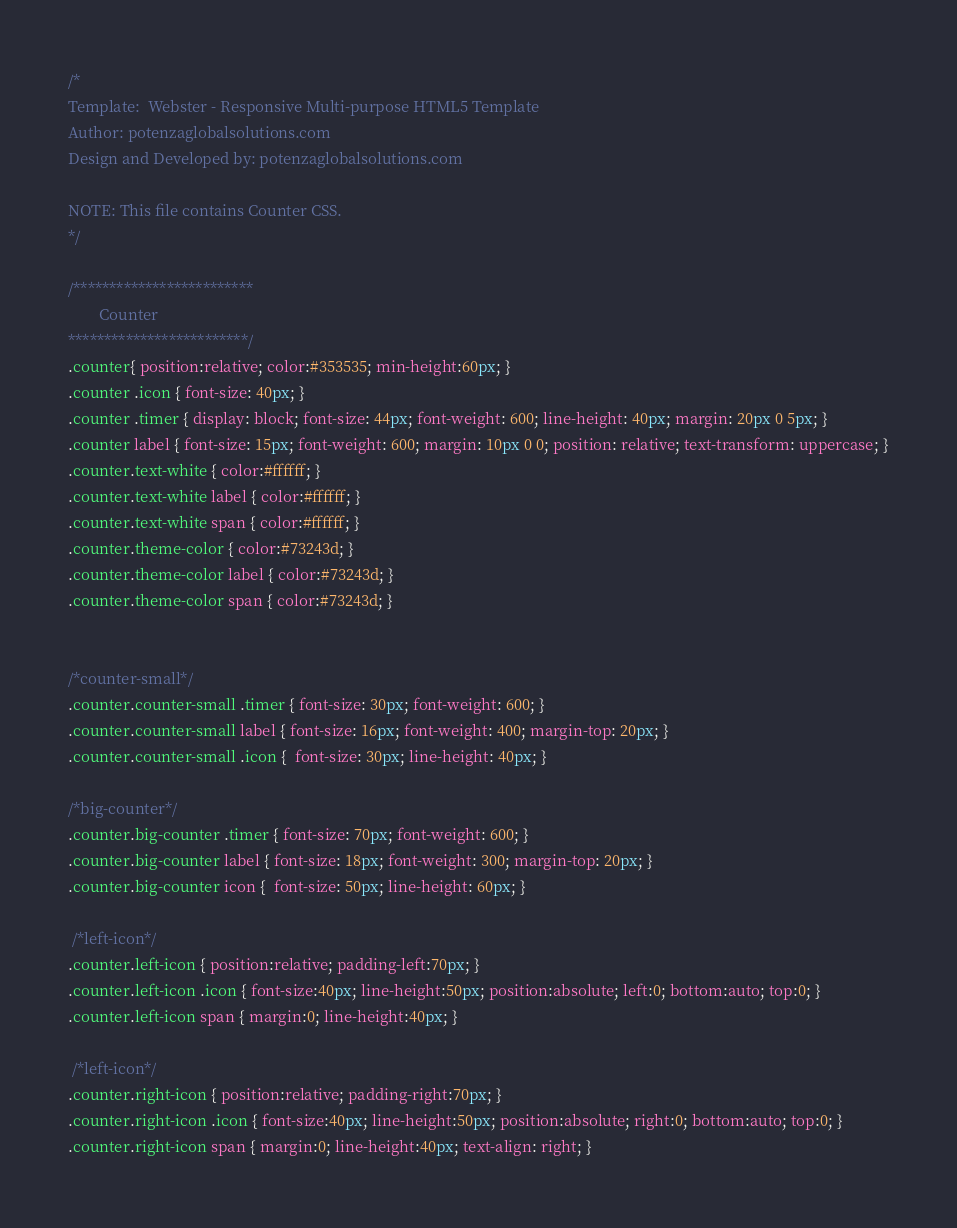<code> <loc_0><loc_0><loc_500><loc_500><_CSS_>/*
Template:  Webster - Responsive Multi-purpose HTML5 Template
Author: potenzaglobalsolutions.com
Design and Developed by: potenzaglobalsolutions.com

NOTE: This file contains Counter CSS.
*/ 

/*************************
        Counter
*************************/
.counter{ position:relative; color:#353535; min-height:60px; }
.counter .icon { font-size: 40px; }
.counter .timer { display: block; font-size: 44px; font-weight: 600; line-height: 40px; margin: 20px 0 5px; }
.counter label { font-size: 15px; font-weight: 600; margin: 10px 0 0; position: relative; text-transform: uppercase; }
.counter.text-white { color:#ffffff; }
.counter.text-white label { color:#ffffff; }
.counter.text-white span { color:#ffffff; }
.counter.theme-color { color:#73243d; }
.counter.theme-color label { color:#73243d; }
.counter.theme-color span { color:#73243d; }


/*counter-small*/
.counter.counter-small .timer { font-size: 30px; font-weight: 600; }
.counter.counter-small label { font-size: 16px; font-weight: 400; margin-top: 20px; }
.counter.counter-small .icon {  font-size: 30px; line-height: 40px; }

/*big-counter*/
.counter.big-counter .timer { font-size: 70px; font-weight: 600; }
.counter.big-counter label { font-size: 18px; font-weight: 300; margin-top: 20px; }
.counter.big-counter icon {  font-size: 50px; line-height: 60px; }

 /*left-icon*/
.counter.left-icon { position:relative; padding-left:70px; }
.counter.left-icon .icon { font-size:40px; line-height:50px; position:absolute; left:0; bottom:auto; top:0; }
.counter.left-icon span { margin:0; line-height:40px; }

 /*left-icon*/
.counter.right-icon { position:relative; padding-right:70px; }
.counter.right-icon .icon { font-size:40px; line-height:50px; position:absolute; right:0; bottom:auto; top:0; }
.counter.right-icon span { margin:0; line-height:40px; text-align: right; }</code> 